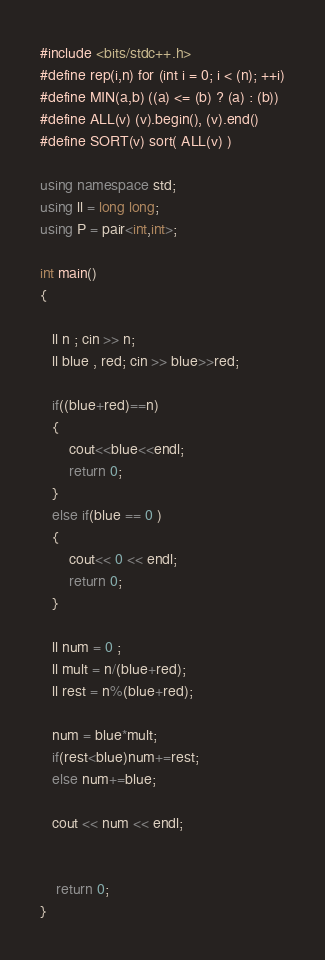Convert code to text. <code><loc_0><loc_0><loc_500><loc_500><_C++_>#include <bits/stdc++.h>
#define rep(i,n) for (int i = 0; i < (n); ++i)
#define MIN(a,b) ((a) <= (b) ? (a) : (b))
#define ALL(v) (v).begin(), (v).end()
#define SORT(v) sort( ALL(v) )

using namespace std;
using ll = long long;
using P = pair<int,int>;

int main()
{

   ll n ; cin >> n;
   ll blue , red; cin >> blue>>red;

   if((blue+red)==n)
   {
       cout<<blue<<endl;
       return 0;
   }
   else if(blue == 0 )
   {
       cout<< 0 << endl;
       return 0;
   }

   ll num = 0 ;
   ll mult = n/(blue+red);
   ll rest = n%(blue+red);

   num = blue*mult;
   if(rest<blue)num+=rest;
   else num+=blue;

   cout << num << endl;


    return 0;
}
</code> 